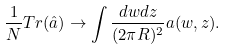Convert formula to latex. <formula><loc_0><loc_0><loc_500><loc_500>\frac { 1 } { N } T r ( \hat { a } ) \rightarrow \int \frac { d w d z } { ( 2 \pi R ) ^ { 2 } } a ( w , z ) .</formula> 